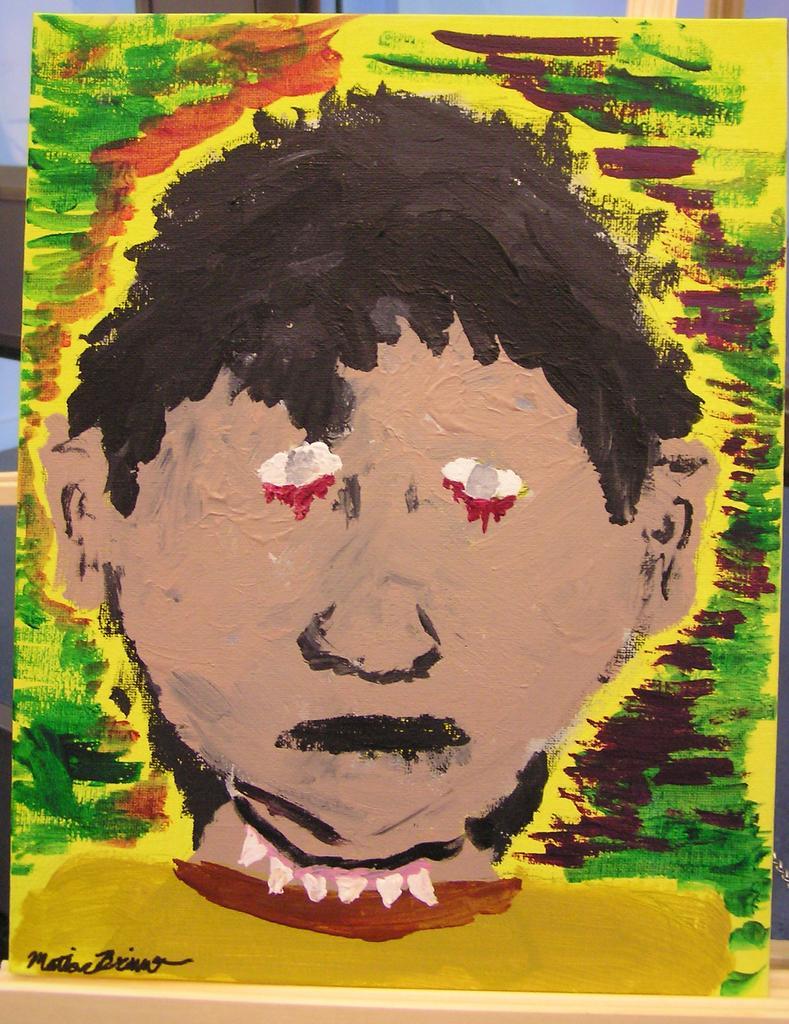In one or two sentences, can you explain what this image depicts? In this picture we can see painting. On the bottom left corner there is a watermark. On the back we can see wooden stand and wall. Here we can see a person's face in the painting. 